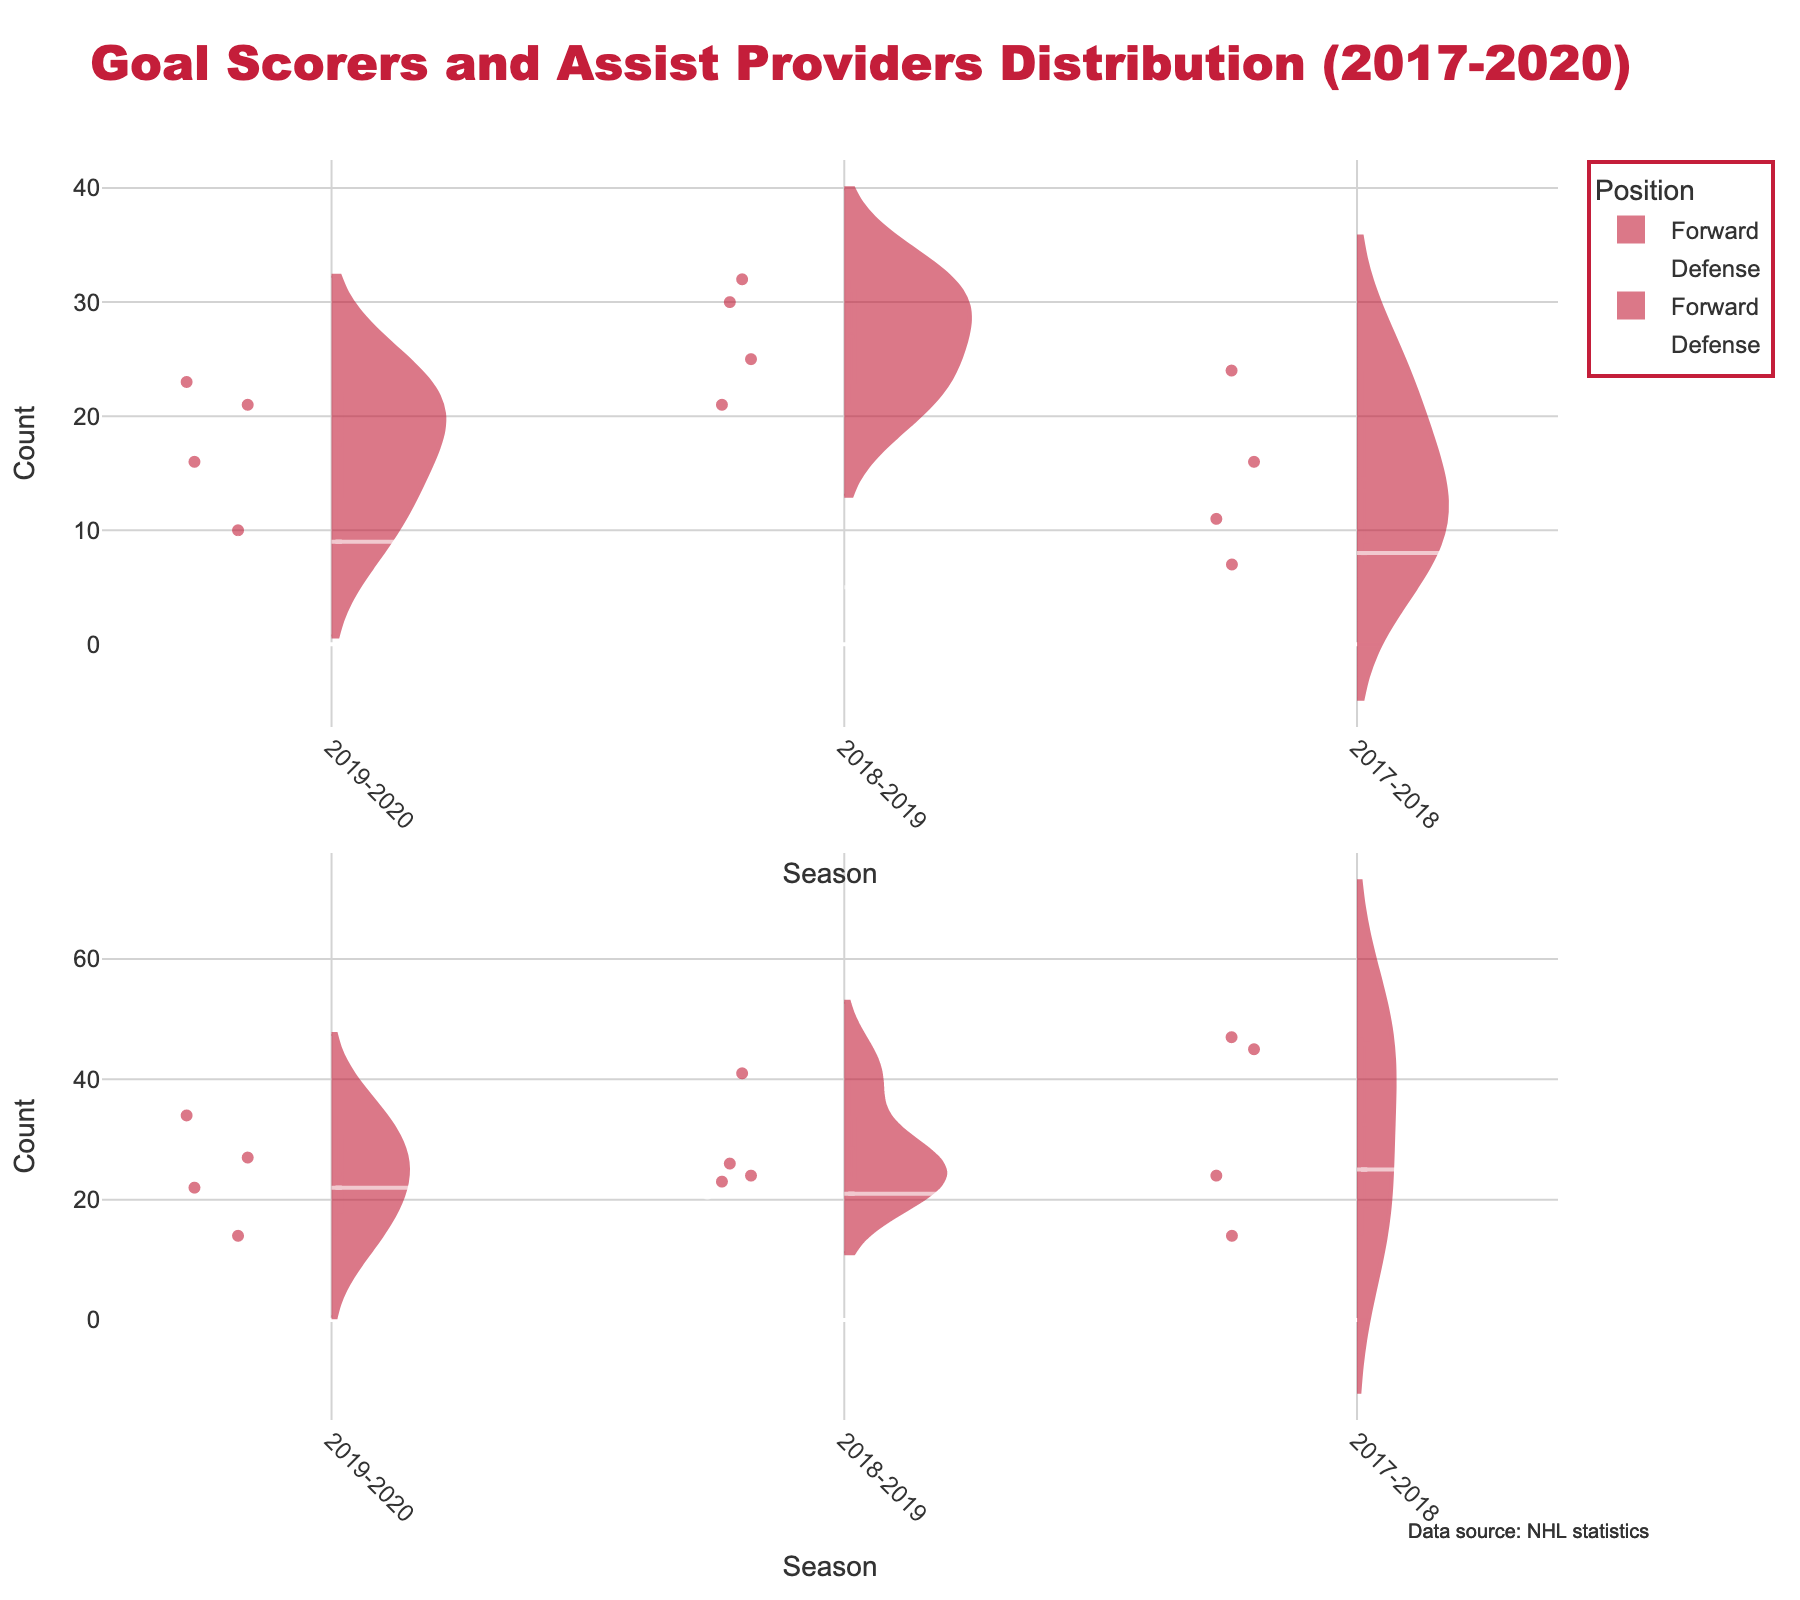What is the total number of goals by forwards in the 2018-2019 season? Identify all forwards in the 2018-2019 season and sum their goals: Dylan Larkin (32), Tyler Bertuzzi (21), Andreas Athanasiou (30), Anthony Mantha (25). The sum is 32 + 21 + 30 + 25 = 108.
Answer: 108 How do the goals scored by forwards compare to those scored by defensemen in the 2019-2020 season? Compare the sum of goals scored by forwards and defensemen: Forwards: Dylan Larkin (23), Tyler Bertuzzi (21), Andreas Athanasiou (10), Anthony Mantha (16). Defensemen: Filip Hronek (9). Total for forwards: 23 + 21 + 10 + 16 = 70, for defensemen: 9.
Answer: Forwards have more goals What is the average number of assists provided by defensemen in the 2017-2018 season? Identify assists provided by defensemen in the 2017-2018 season: Mike Green (25). As there is only one data point, the average is 25.
Answer: 25 Which season had the highest median number of goals scored by forwards? Inspect the median values of goals scored by forwards in each season from the violin chart. The 2018-2019 season appears to have a higher median based on the distribution spread.
Answer: 2018-2019 Does any player show a declining trend in goals over the seasons? Examine the trend of each player's goals from 2017-2020. Dylan Larkin increased from 2017-2018 (16) to 2018-2019 (32) but declined to 2019-2020 (23). This indicates a declining trend from 2018-2019 to 2019-2020.
Answer: Dylan Larkin How does the distribution of assists for forwards compare to defensemen in the 2017-2018 season? Compare the spread and central tendencies of assists for both positions. The violin chart for forwards will show a wider spread and higher median compared to defensemen, who have fewer assists but a more compact distribution.
Answer: Forwards have a wider spread Which player had the most significant range in goals scored across the seasons? Look at the individual range for each player's goals across three seasons using the violin charts. Dylan Larkin’s range is 32 - 16 = 16.
Answer: Dylan Larkin Are there any players who provided more assists than goals in every season? Identify players who consistently have higher assists than goals each season. Dylan Larkin (34 vs 23 in 2019-2020, 41 vs 32 in 2018-2019, 47 vs 16 in 2017-2018).
Answer: Dylan Larkin 